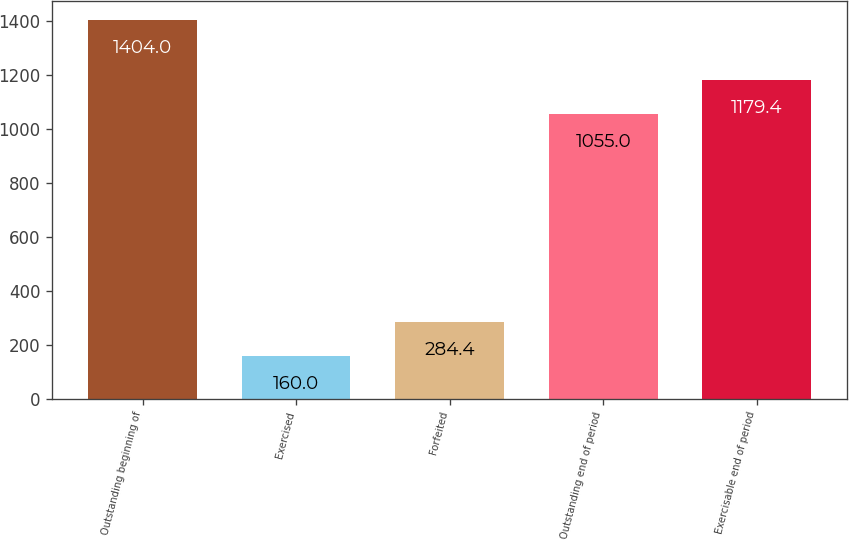Convert chart. <chart><loc_0><loc_0><loc_500><loc_500><bar_chart><fcel>Outstanding beginning of<fcel>Exercised<fcel>Forfeited<fcel>Outstanding end of period<fcel>Exercisable end of period<nl><fcel>1404<fcel>160<fcel>284.4<fcel>1055<fcel>1179.4<nl></chart> 